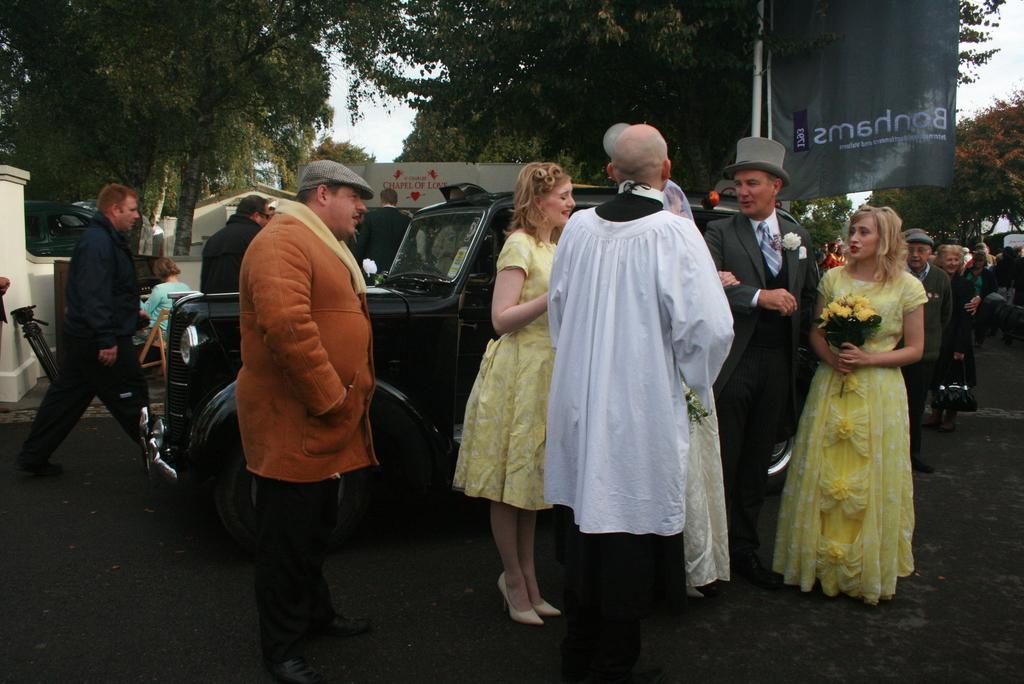Could you give a brief overview of what you see in this image? In this image few persons are standing on the road. They are before a car. Few persons are walking on the road. A person is sitting on the chair. There is a stand near the wall. A woman wearing a yellow dress is holding a bouquet. A person wearing a suit and tie is wearing a cap. A woman is wearing a yellow dress. A person is wearing a orange jacket and cap. Right side few persons are standing on the land. There is a banner attached to the pole. Behind person's there are few trees and sky. 